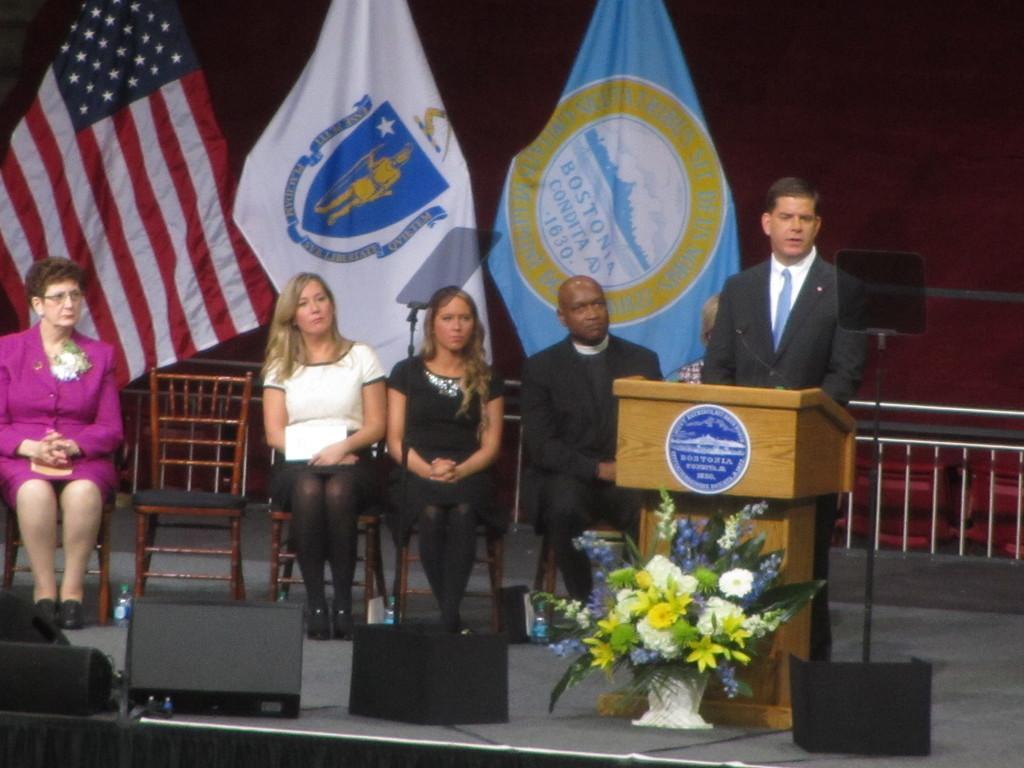Please provide a concise description of this image. In the picture they are five people sitting on chairs and one is standing and giving speech. In the background they are three flags and wall. And on the floor they are flowers. 